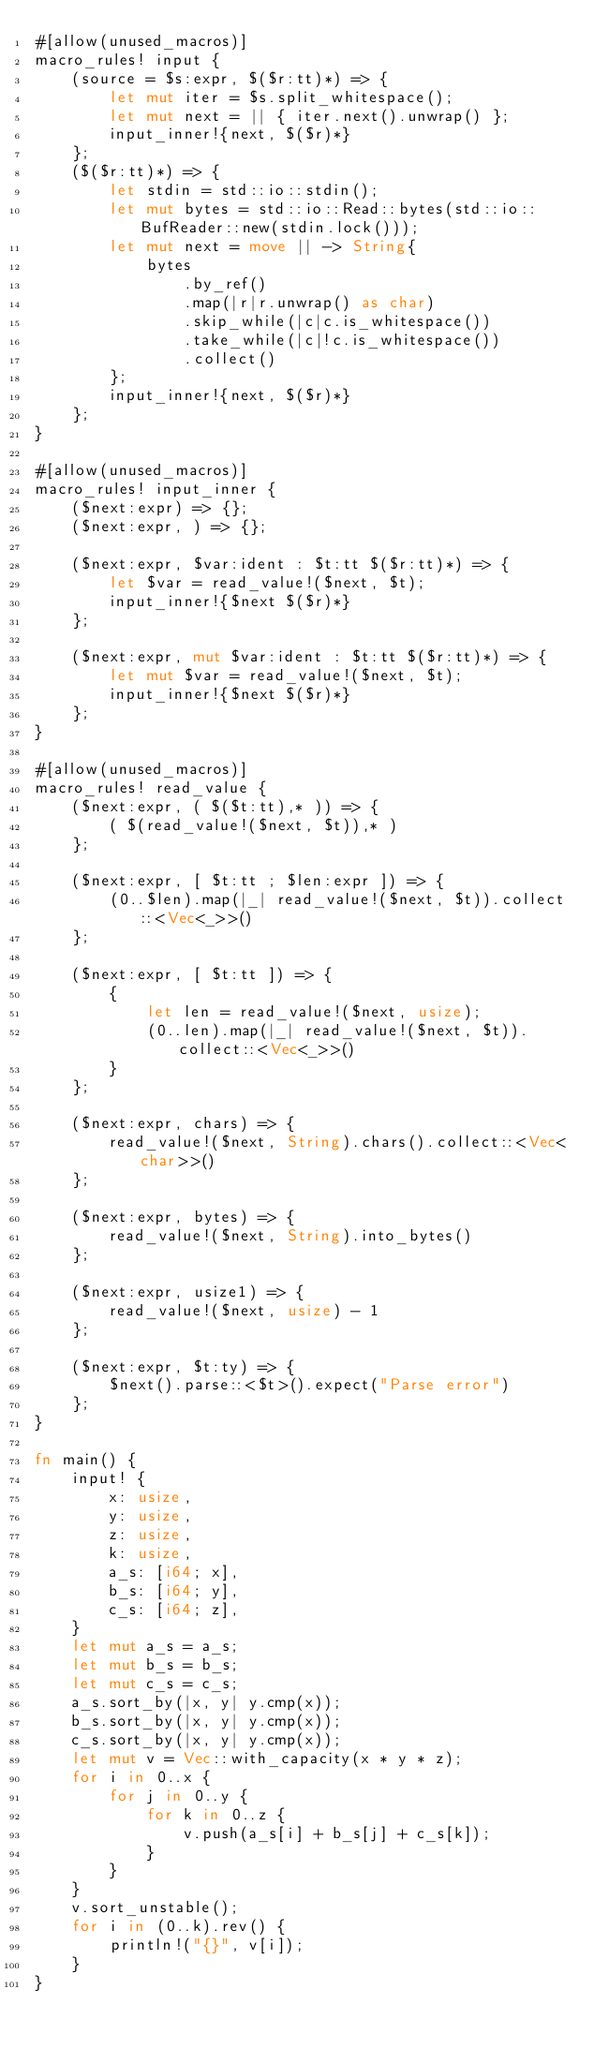Convert code to text. <code><loc_0><loc_0><loc_500><loc_500><_Rust_>#[allow(unused_macros)]
macro_rules! input {
    (source = $s:expr, $($r:tt)*) => {
        let mut iter = $s.split_whitespace();
        let mut next = || { iter.next().unwrap() };
        input_inner!{next, $($r)*}
    };
    ($($r:tt)*) => {
        let stdin = std::io::stdin();
        let mut bytes = std::io::Read::bytes(std::io::BufReader::new(stdin.lock()));
        let mut next = move || -> String{
            bytes
                .by_ref()
                .map(|r|r.unwrap() as char)
                .skip_while(|c|c.is_whitespace())
                .take_while(|c|!c.is_whitespace())
                .collect()
        };
        input_inner!{next, $($r)*}
    };
}

#[allow(unused_macros)]
macro_rules! input_inner {
    ($next:expr) => {};
    ($next:expr, ) => {};

    ($next:expr, $var:ident : $t:tt $($r:tt)*) => {
        let $var = read_value!($next, $t);
        input_inner!{$next $($r)*}
    };

    ($next:expr, mut $var:ident : $t:tt $($r:tt)*) => {
        let mut $var = read_value!($next, $t);
        input_inner!{$next $($r)*}
    };
}

#[allow(unused_macros)]
macro_rules! read_value {
    ($next:expr, ( $($t:tt),* )) => {
        ( $(read_value!($next, $t)),* )
    };

    ($next:expr, [ $t:tt ; $len:expr ]) => {
        (0..$len).map(|_| read_value!($next, $t)).collect::<Vec<_>>()
    };

    ($next:expr, [ $t:tt ]) => {
        {
            let len = read_value!($next, usize);
            (0..len).map(|_| read_value!($next, $t)).collect::<Vec<_>>()
        }
    };

    ($next:expr, chars) => {
        read_value!($next, String).chars().collect::<Vec<char>>()
    };

    ($next:expr, bytes) => {
        read_value!($next, String).into_bytes()
    };

    ($next:expr, usize1) => {
        read_value!($next, usize) - 1
    };

    ($next:expr, $t:ty) => {
        $next().parse::<$t>().expect("Parse error")
    };
}

fn main() {
    input! {
        x: usize,
        y: usize,
        z: usize,
        k: usize,
        a_s: [i64; x],
        b_s: [i64; y],
        c_s: [i64; z],
    }
    let mut a_s = a_s;
    let mut b_s = b_s;
    let mut c_s = c_s;
    a_s.sort_by(|x, y| y.cmp(x));
    b_s.sort_by(|x, y| y.cmp(x));
    c_s.sort_by(|x, y| y.cmp(x));
    let mut v = Vec::with_capacity(x * y * z);
    for i in 0..x {
        for j in 0..y {
            for k in 0..z {
                v.push(a_s[i] + b_s[j] + c_s[k]);
            }
        }
    }
    v.sort_unstable();
    for i in (0..k).rev() {
        println!("{}", v[i]);
    }
}
</code> 